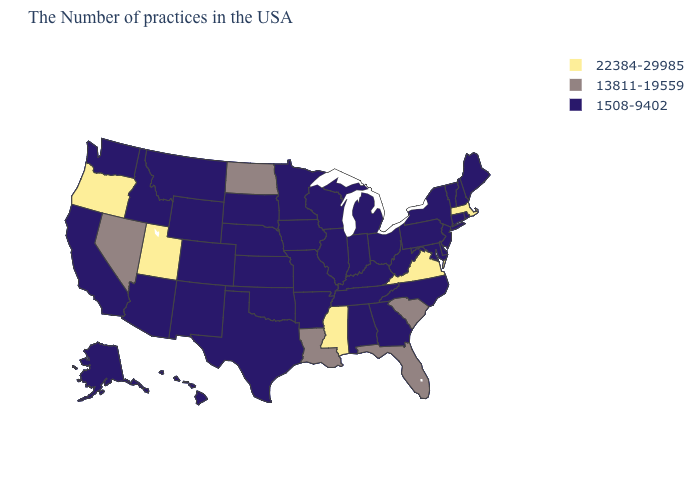Name the states that have a value in the range 22384-29985?
Write a very short answer. Massachusetts, Virginia, Mississippi, Utah, Oregon. Name the states that have a value in the range 1508-9402?
Keep it brief. Maine, Rhode Island, New Hampshire, Vermont, Connecticut, New York, New Jersey, Delaware, Maryland, Pennsylvania, North Carolina, West Virginia, Ohio, Georgia, Michigan, Kentucky, Indiana, Alabama, Tennessee, Wisconsin, Illinois, Missouri, Arkansas, Minnesota, Iowa, Kansas, Nebraska, Oklahoma, Texas, South Dakota, Wyoming, Colorado, New Mexico, Montana, Arizona, Idaho, California, Washington, Alaska, Hawaii. How many symbols are there in the legend?
Keep it brief. 3. Name the states that have a value in the range 1508-9402?
Concise answer only. Maine, Rhode Island, New Hampshire, Vermont, Connecticut, New York, New Jersey, Delaware, Maryland, Pennsylvania, North Carolina, West Virginia, Ohio, Georgia, Michigan, Kentucky, Indiana, Alabama, Tennessee, Wisconsin, Illinois, Missouri, Arkansas, Minnesota, Iowa, Kansas, Nebraska, Oklahoma, Texas, South Dakota, Wyoming, Colorado, New Mexico, Montana, Arizona, Idaho, California, Washington, Alaska, Hawaii. How many symbols are there in the legend?
Concise answer only. 3. Does Minnesota have the highest value in the MidWest?
Write a very short answer. No. Does the map have missing data?
Write a very short answer. No. Name the states that have a value in the range 13811-19559?
Be succinct. South Carolina, Florida, Louisiana, North Dakota, Nevada. Among the states that border Colorado , which have the lowest value?
Write a very short answer. Kansas, Nebraska, Oklahoma, Wyoming, New Mexico, Arizona. What is the value of South Dakota?
Short answer required. 1508-9402. What is the value of Massachusetts?
Short answer required. 22384-29985. What is the highest value in the South ?
Answer briefly. 22384-29985. Name the states that have a value in the range 1508-9402?
Write a very short answer. Maine, Rhode Island, New Hampshire, Vermont, Connecticut, New York, New Jersey, Delaware, Maryland, Pennsylvania, North Carolina, West Virginia, Ohio, Georgia, Michigan, Kentucky, Indiana, Alabama, Tennessee, Wisconsin, Illinois, Missouri, Arkansas, Minnesota, Iowa, Kansas, Nebraska, Oklahoma, Texas, South Dakota, Wyoming, Colorado, New Mexico, Montana, Arizona, Idaho, California, Washington, Alaska, Hawaii. Name the states that have a value in the range 22384-29985?
Keep it brief. Massachusetts, Virginia, Mississippi, Utah, Oregon. 